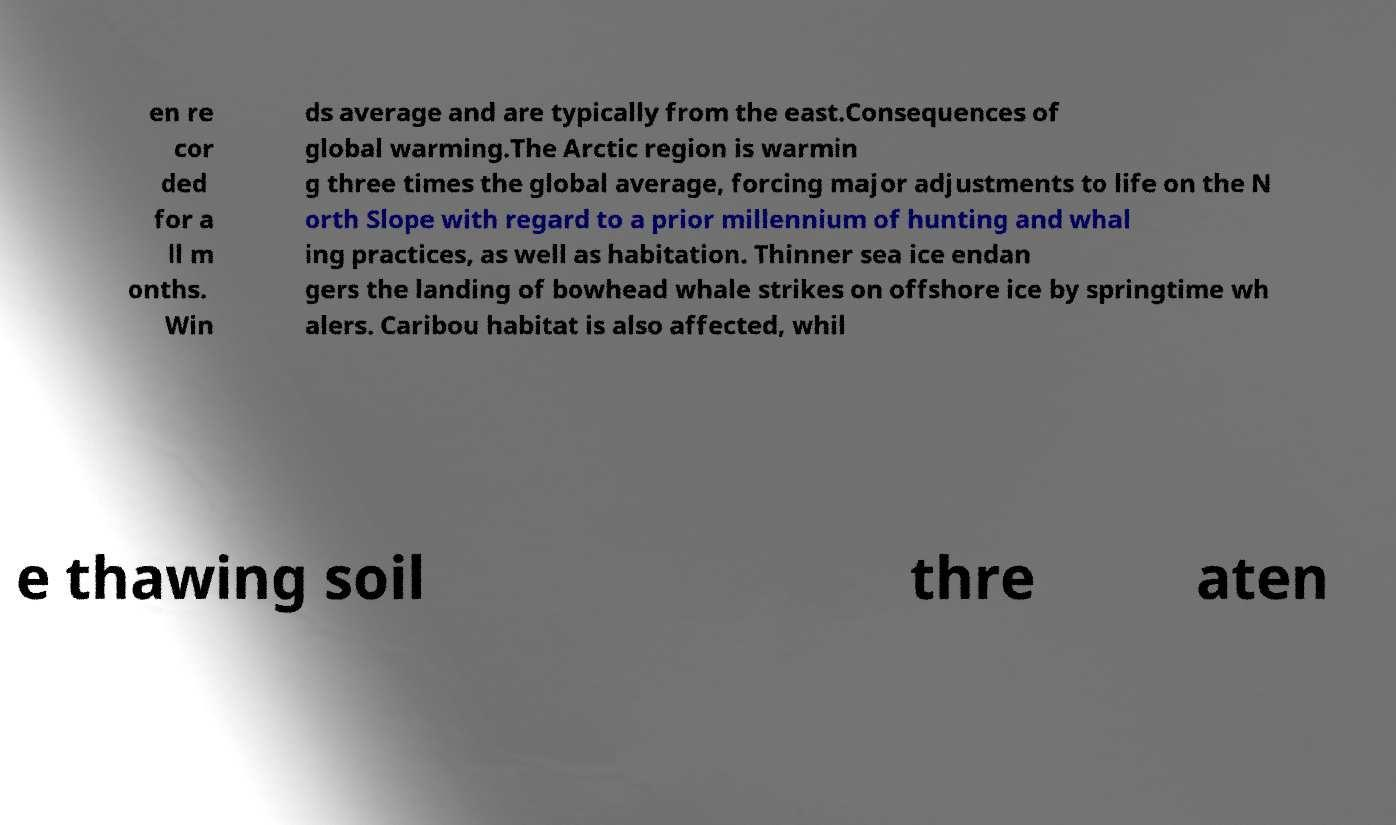Please identify and transcribe the text found in this image. en re cor ded for a ll m onths. Win ds average and are typically from the east.Consequences of global warming.The Arctic region is warmin g three times the global average, forcing major adjustments to life on the N orth Slope with regard to a prior millennium of hunting and whal ing practices, as well as habitation. Thinner sea ice endan gers the landing of bowhead whale strikes on offshore ice by springtime wh alers. Caribou habitat is also affected, whil e thawing soil thre aten 